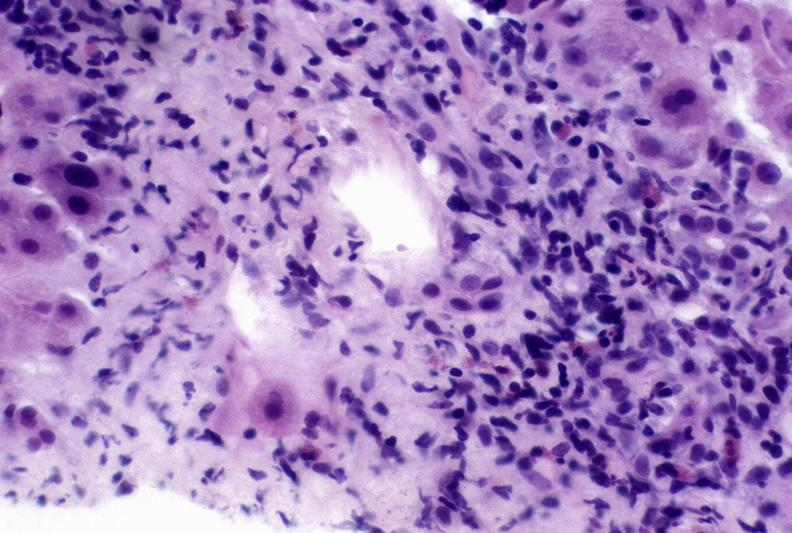s hepatobiliary present?
Answer the question using a single word or phrase. Yes 